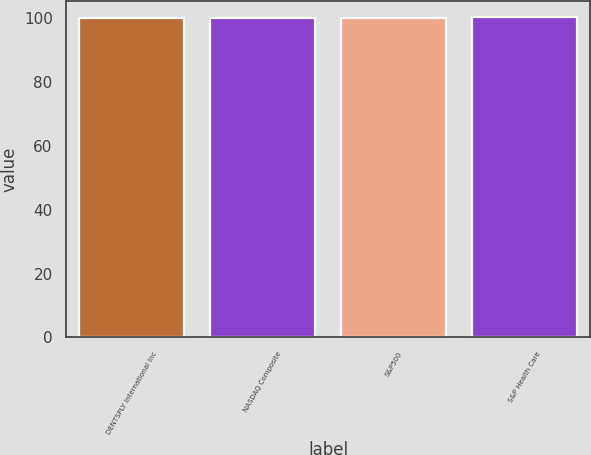<chart> <loc_0><loc_0><loc_500><loc_500><bar_chart><fcel>DENTSPLY International Inc<fcel>NASDAQ Composite<fcel>S&P500<fcel>S&P Health Care<nl><fcel>100<fcel>100.1<fcel>100.2<fcel>100.3<nl></chart> 